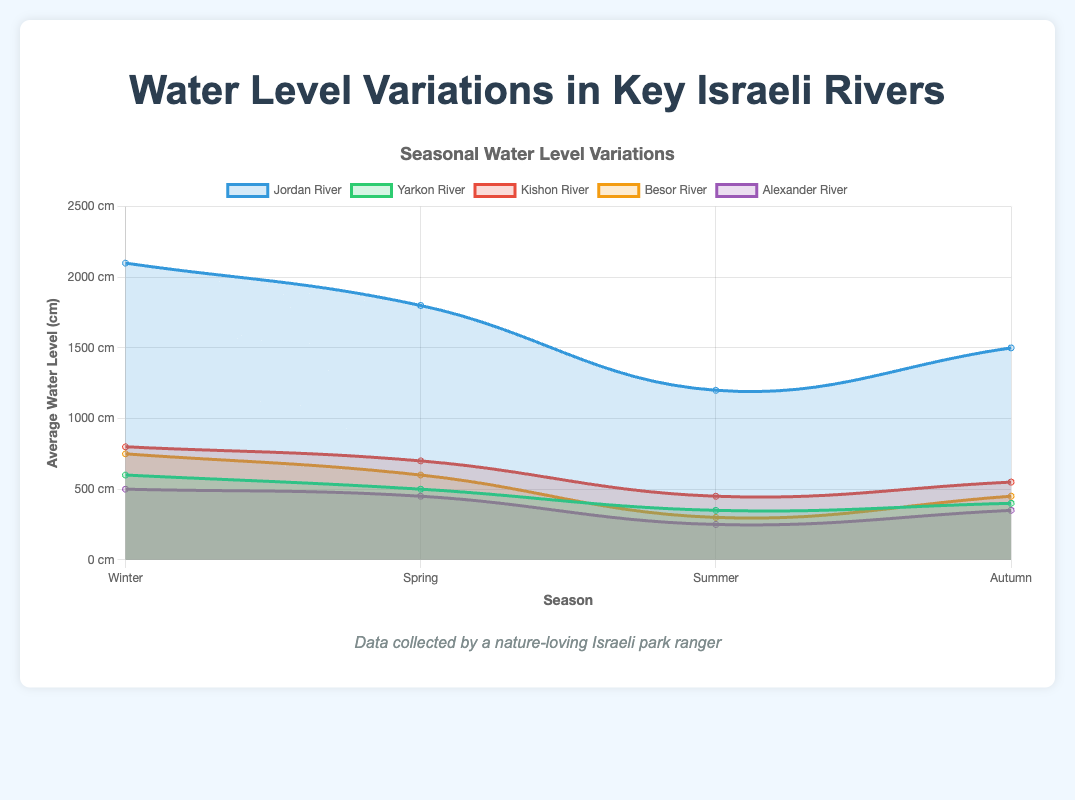Which river has the highest average water level in Winter? The Jordan River has the highest average water level in Winter as its value is 2100 cm, which is higher than any other river's average water level for the same season.
Answer: Jordan River What is the difference in average water levels between Winter and Summer for the Jordan River? To find the difference, subtract the average water level in Summer (1200 cm) from the average water level in Winter (2100 cm). The calculation is 2100 - 1200 = 900 cm.
Answer: 900 cm Which season has the lowest average water level for the Yarkon River? Reviewing the data, the Summer season has the lowest average water level for the Yarkon River at 350 cm compared to other seasons.
Answer: Summer Compare the average water level of the Kishon River in Spring and Autumn and state which season has a higher level. The average water level in Spring is 700 cm whereas in Autumn it is 550 cm. The Spring season has a higher average water level.
Answer: Spring Calculate the average water level for the Besor River across all seasons. Sum the average water levels across all seasons (750 + 600 + 300 + 450 = 2100 cm) and divide by the number of seasons (4): 2100 / 4 = 525 cm.
Answer: 525 cm Which river experiences the greatest fluctuation in water level from Winter to Summer? Calculate the fluctuation for each river and compare.
Jordan River: 2100 - 1200 = 900 cm
Yarkon River: 600 - 350 = 250 cm
Kishon River: 800 - 450 = 350 cm
Besor River: 750 - 300 = 450 cm
Alexander River: 500 - 250 = 250 cm
The Jordan River experiences the greatest fluctuation of 900 cm.
Answer: Jordan River During which season does the Alexander River reach its second highest average water level? The highest average water level is in Winter (500 cm), and the second highest is in Spring (450 cm).
Answer: Spring What is the sum of the average water levels of all rivers in Autumn? Sum the average water levels for all rivers in Autumn (1500 + 400 + 550 + 450 + 350): 1500 + 400 + 550 + 450 + 350 = 3250 cm.
Answer: 3250 cm 